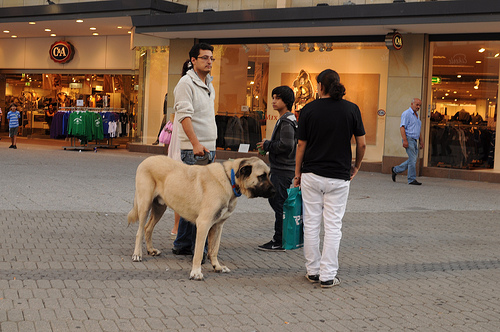Describe the expressions of the people around the dog. The expressions of the people around the dog seem relaxed and friendly, indicative of a pleasant interaction among the group, perhaps discussing their day or plans while patting the dog. Do the people appear to know each other? Yes, the people appear to know each other, shown by their comfortable proximity and relaxed engagement, suggesting they are together as a group. 